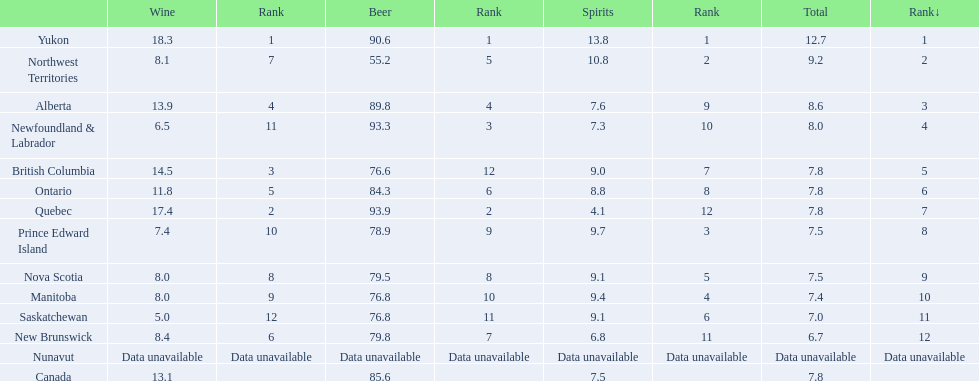What are all the canadian regions? Yukon, Northwest Territories, Alberta, Newfoundland & Labrador, British Columbia, Ontario, Quebec, Prince Edward Island, Nova Scotia, Manitoba, Saskatchewan, New Brunswick, Nunavut, Canada. What was the spirits consumption? 13.8, 10.8, 7.6, 7.3, 9.0, 8.8, 4.1, 9.7, 9.1, 9.4, 9.1, 6.8, Data unavailable, 7.5. What was quebec's spirit consumption? 4.1. 